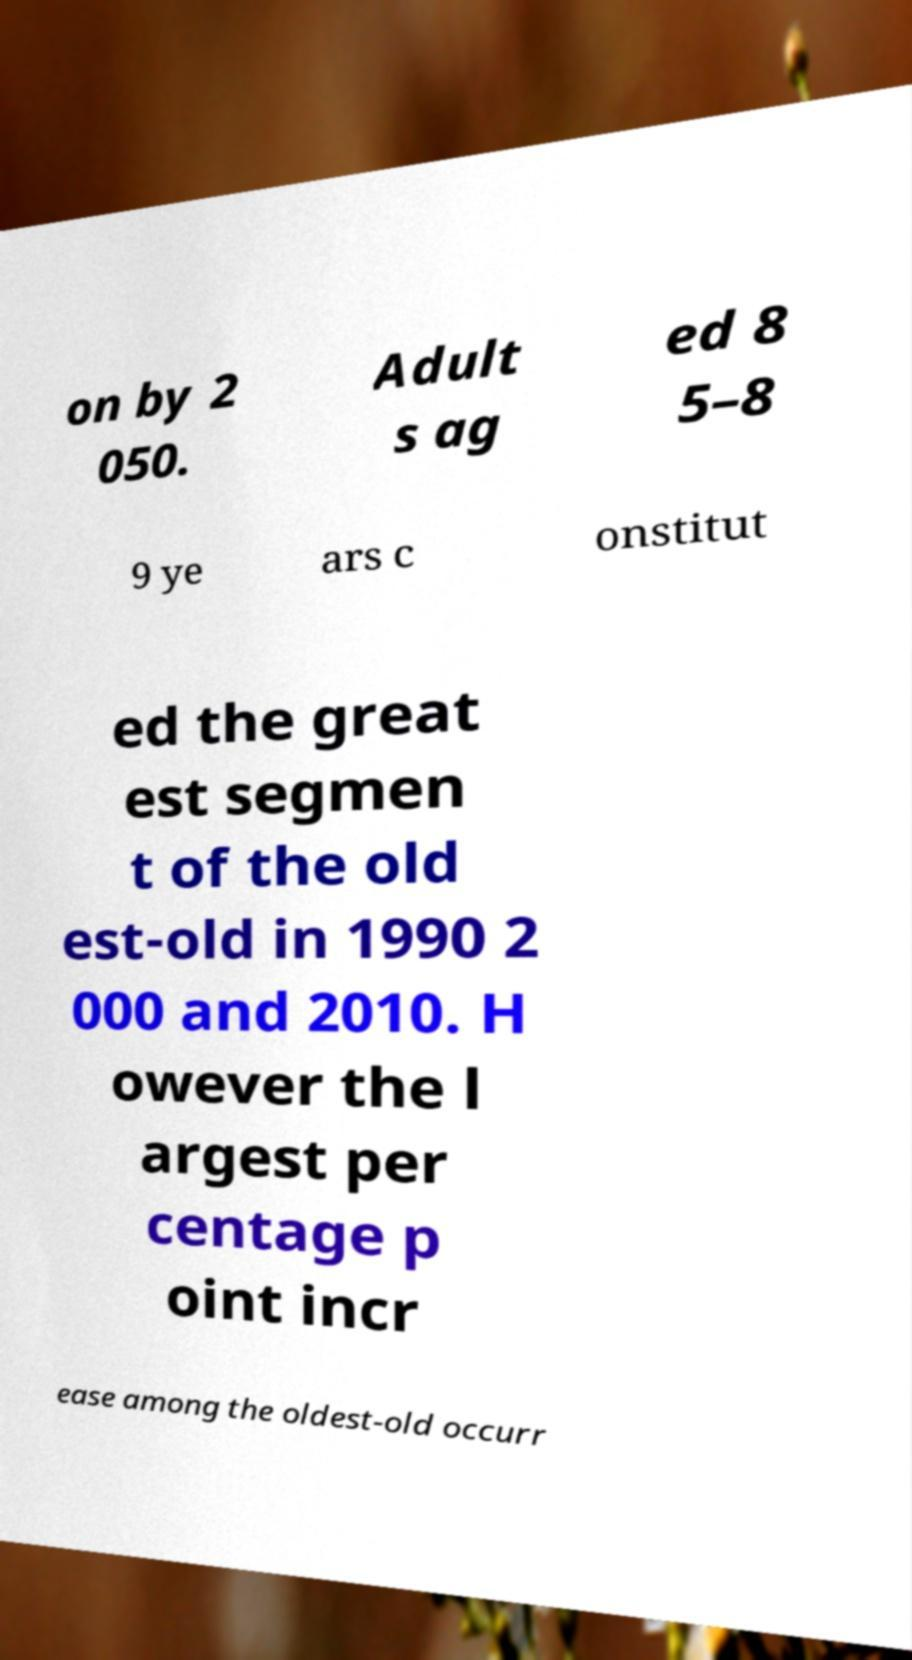Please identify and transcribe the text found in this image. on by 2 050. Adult s ag ed 8 5–8 9 ye ars c onstitut ed the great est segmen t of the old est-old in 1990 2 000 and 2010. H owever the l argest per centage p oint incr ease among the oldest-old occurr 